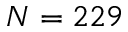<formula> <loc_0><loc_0><loc_500><loc_500>N = 2 2 9</formula> 